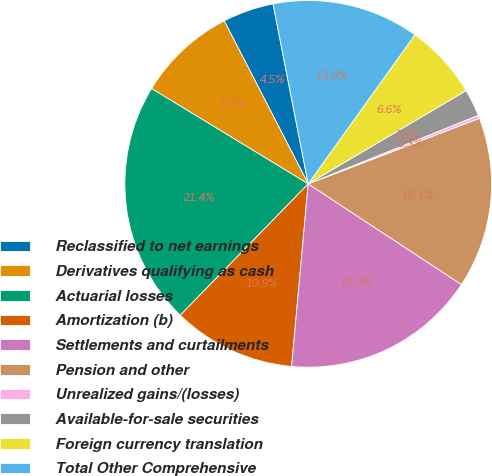Convert chart to OTSL. <chart><loc_0><loc_0><loc_500><loc_500><pie_chart><fcel>Reclassified to net earnings<fcel>Derivatives qualifying as cash<fcel>Actuarial losses<fcel>Amortization (b)<fcel>Settlements and curtailments<fcel>Pension and other<fcel>Unrealized gains/(losses)<fcel>Available-for-sale securities<fcel>Foreign currency translation<fcel>Total Other Comprehensive<nl><fcel>4.5%<fcel>8.73%<fcel>21.41%<fcel>10.85%<fcel>17.19%<fcel>15.07%<fcel>0.28%<fcel>2.39%<fcel>6.62%<fcel>12.96%<nl></chart> 